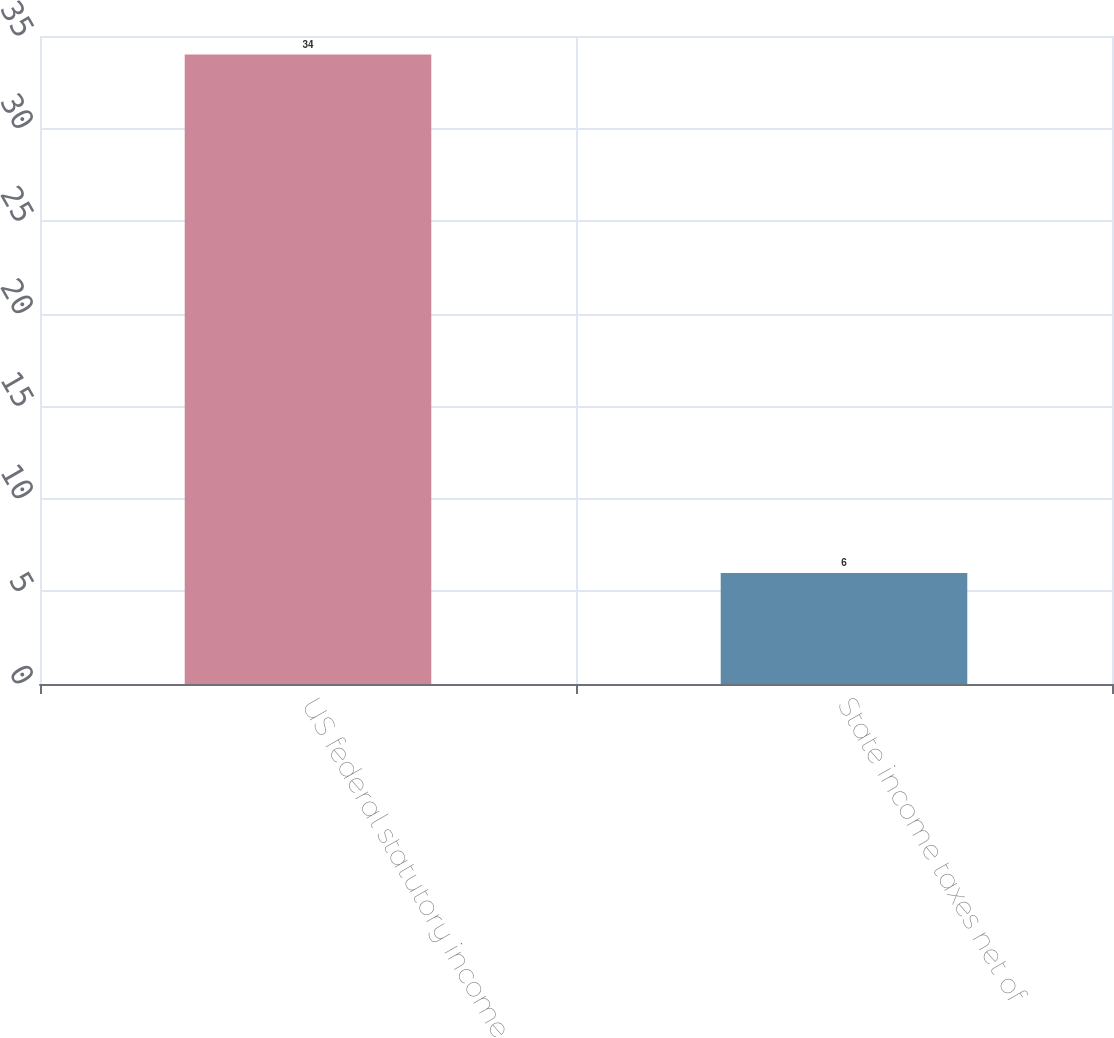Convert chart to OTSL. <chart><loc_0><loc_0><loc_500><loc_500><bar_chart><fcel>US federal statutory income<fcel>State income taxes net of<nl><fcel>34<fcel>6<nl></chart> 